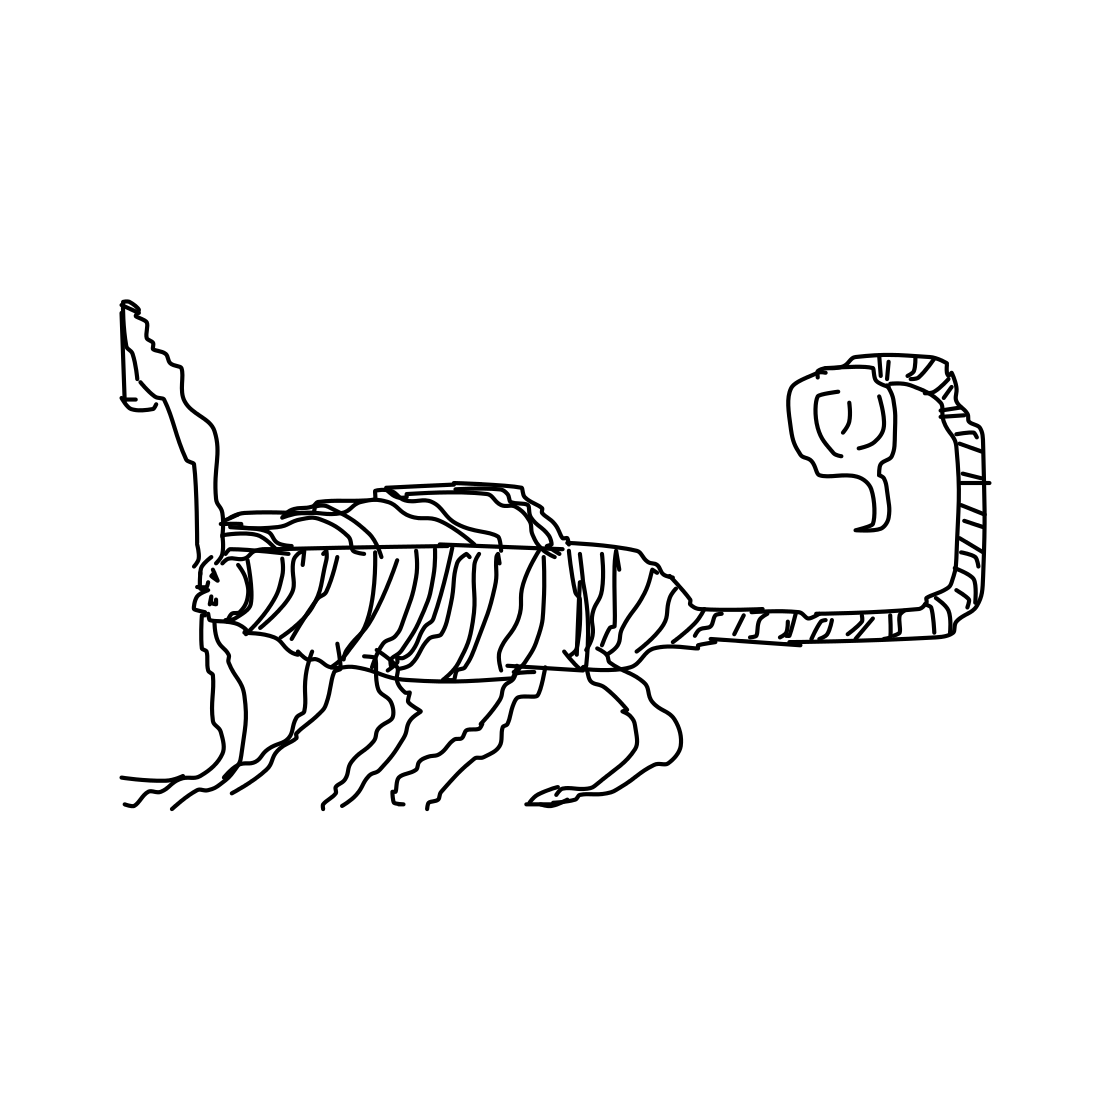Could you suggest an environment where this creature might live? This creature, with its sinuous lines and delicate structure, looks like it could belong in an ethereal, dreamlike forest. It's easy to imagine it residing among towering trees with translucent leaves, where the laws of nature are as fluid and enigmatic as its own form. 